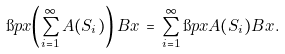<formula> <loc_0><loc_0><loc_500><loc_500>\i p { x } { \left ( \sum _ { i = 1 } ^ { \infty } A ( S _ { i } ) \right ) B x } \, = \, \sum _ { i = 1 } ^ { \infty } \i p { x } { A ( S _ { i } ) B x } .</formula> 